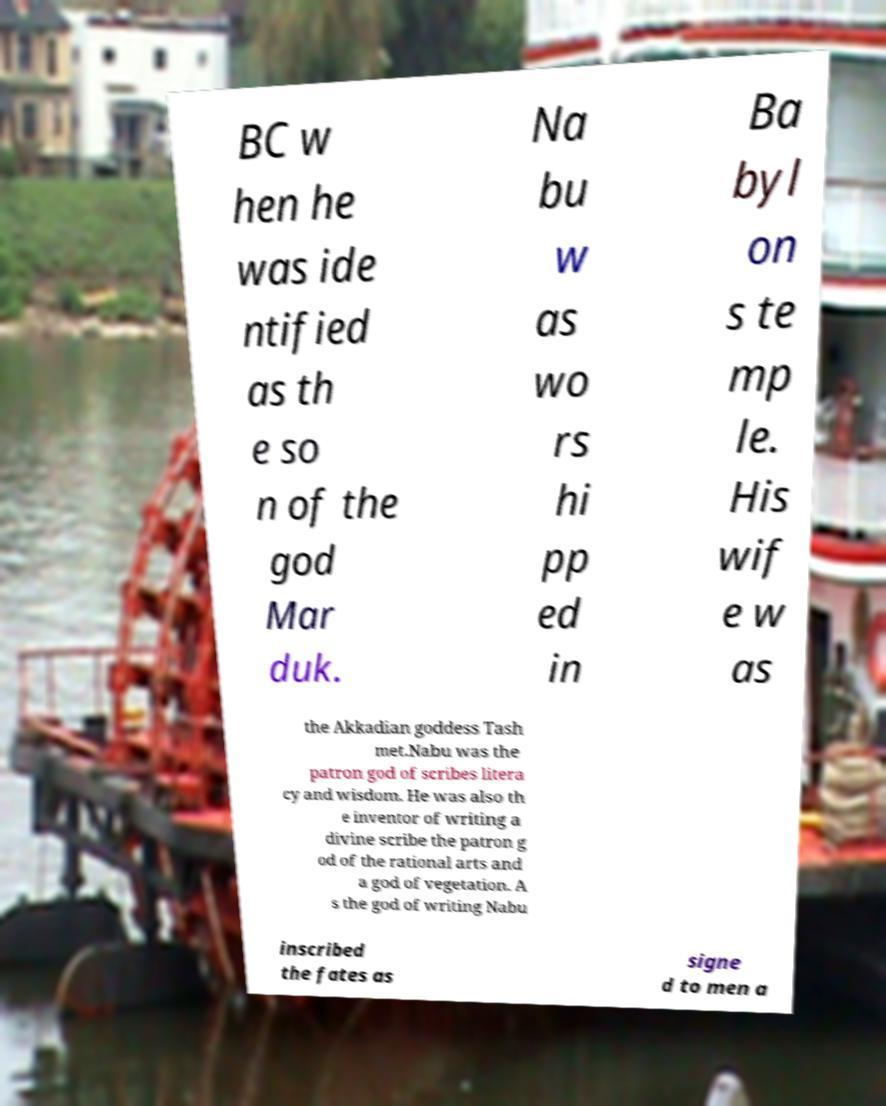Could you assist in decoding the text presented in this image and type it out clearly? BC w hen he was ide ntified as th e so n of the god Mar duk. Na bu w as wo rs hi pp ed in Ba byl on s te mp le. His wif e w as the Akkadian goddess Tash met.Nabu was the patron god of scribes litera cy and wisdom. He was also th e inventor of writing a divine scribe the patron g od of the rational arts and a god of vegetation. A s the god of writing Nabu inscribed the fates as signe d to men a 